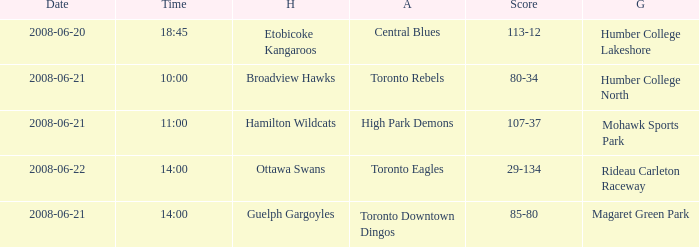What is the Time with a Ground that is humber college north? 10:00. 